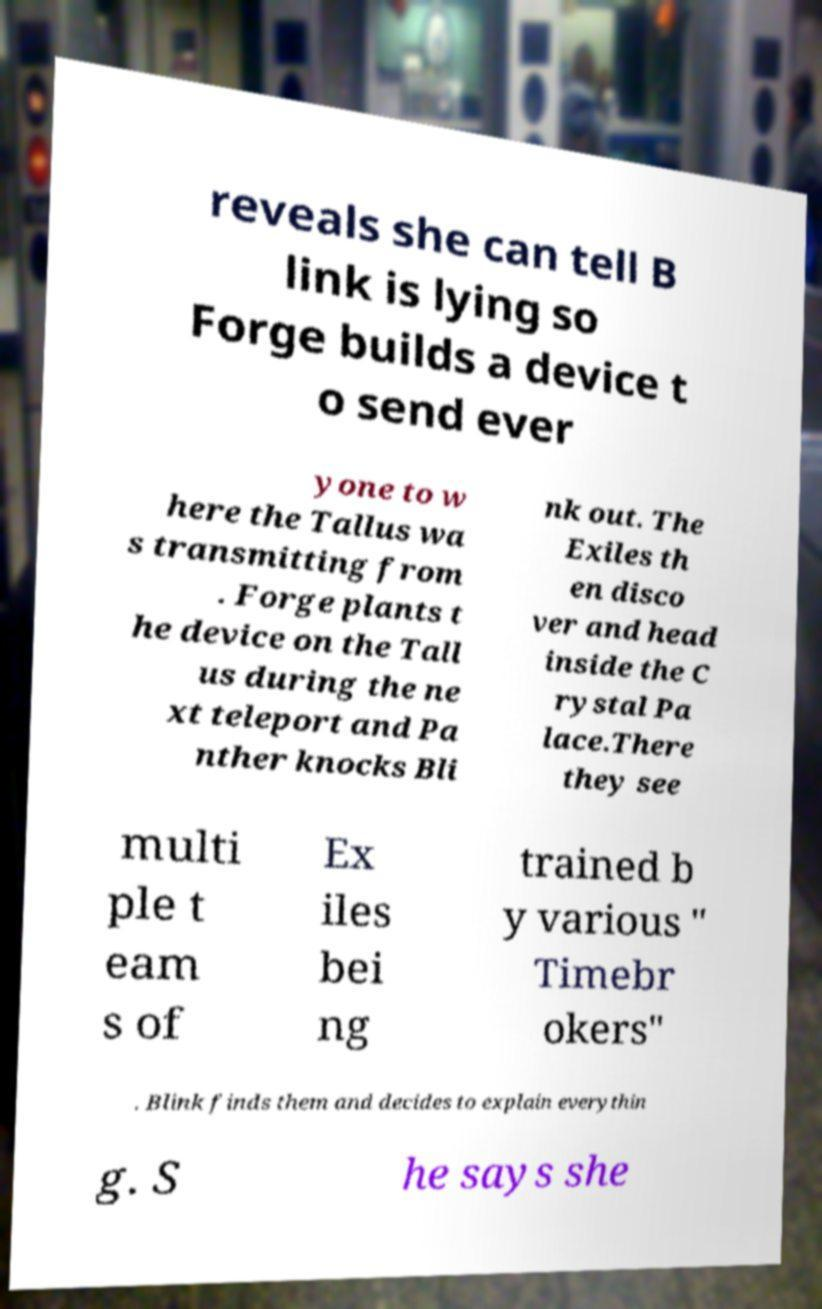Please identify and transcribe the text found in this image. reveals she can tell B link is lying so Forge builds a device t o send ever yone to w here the Tallus wa s transmitting from . Forge plants t he device on the Tall us during the ne xt teleport and Pa nther knocks Bli nk out. The Exiles th en disco ver and head inside the C rystal Pa lace.There they see multi ple t eam s of Ex iles bei ng trained b y various " Timebr okers" . Blink finds them and decides to explain everythin g. S he says she 